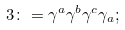<formula> <loc_0><loc_0><loc_500><loc_500>3 \colon = { \gamma } ^ { a } { \gamma } ^ { b } { \gamma } ^ { c } { \gamma } _ { a } ;</formula> 